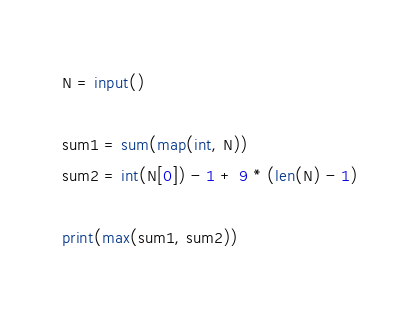<code> <loc_0><loc_0><loc_500><loc_500><_Python_>N = input()

sum1 = sum(map(int, N))
sum2 = int(N[0]) - 1 + 9 * (len(N) - 1)

print(max(sum1, sum2))
</code> 